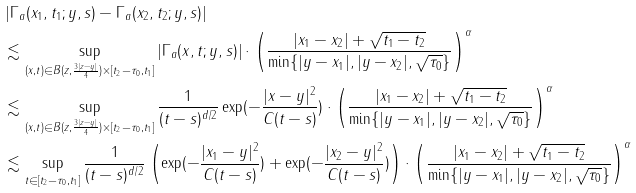<formula> <loc_0><loc_0><loc_500><loc_500>& \left | \Gamma _ { a } ( x _ { 1 } , t _ { 1 } ; y , s ) - \Gamma _ { a } ( x _ { 2 } , t _ { 2 } ; y , s ) \right | \\ & \lesssim \sup _ { ( x , t ) \in B ( z , \frac { 3 | z - y | } { 4 } ) \times [ t _ { 2 } - \tau _ { 0 } , t _ { 1 } ] } \left | \Gamma _ { a } ( x , t ; y , s ) \right | \cdot \left ( \frac { | x _ { 1 } - x _ { 2 } | + \sqrt { t _ { 1 } - t _ { 2 } } } { \min \{ | y - x _ { 1 } | , | y - x _ { 2 } | , \sqrt { \tau _ { 0 } } \} } \right ) ^ { \alpha } \\ & \lesssim \sup _ { ( x , t ) \in B ( z , \frac { 3 | z - y | } { 4 } ) \times [ t _ { 2 } - \tau _ { 0 } , t _ { 1 } ] } \frac { 1 } { ( t - s ) ^ { d / 2 } } \exp ( - \frac { | x - y | ^ { 2 } } { C ( t - s ) } ) \cdot \left ( \frac { | x _ { 1 } - x _ { 2 } | + \sqrt { t _ { 1 } - t _ { 2 } } } { \min \{ | y - x _ { 1 } | , | y - x _ { 2 } | , \sqrt { \tau _ { 0 } } \} } \right ) ^ { \alpha } \\ & \lesssim \sup _ { t \in [ t _ { 2 } - \tau _ { 0 } , t _ { 1 } ] } \frac { 1 } { ( t - s ) ^ { d / 2 } } \left ( \exp ( - \frac { | x _ { 1 } - y | ^ { 2 } } { C ( t - s ) } ) + \exp ( - \frac { | x _ { 2 } - y | ^ { 2 } } { C ( t - s ) } ) \right ) \cdot \left ( \frac { | x _ { 1 } - x _ { 2 } | + \sqrt { t _ { 1 } - t _ { 2 } } } { \min \{ | y - x _ { 1 } | , | y - x _ { 2 } | , \sqrt { \tau _ { 0 } } \} } \right ) ^ { \alpha } \\</formula> 